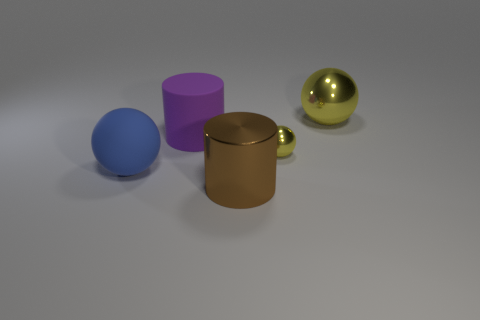Do the big purple rubber thing and the large blue matte thing have the same shape? The big purple rubber object is cylindrical, whereas the large blue matte object is spherical. Although they are both simply shaped and prominently featured, their shapes are quite distinct: one is a cylinder, and the other resembles a ball. 